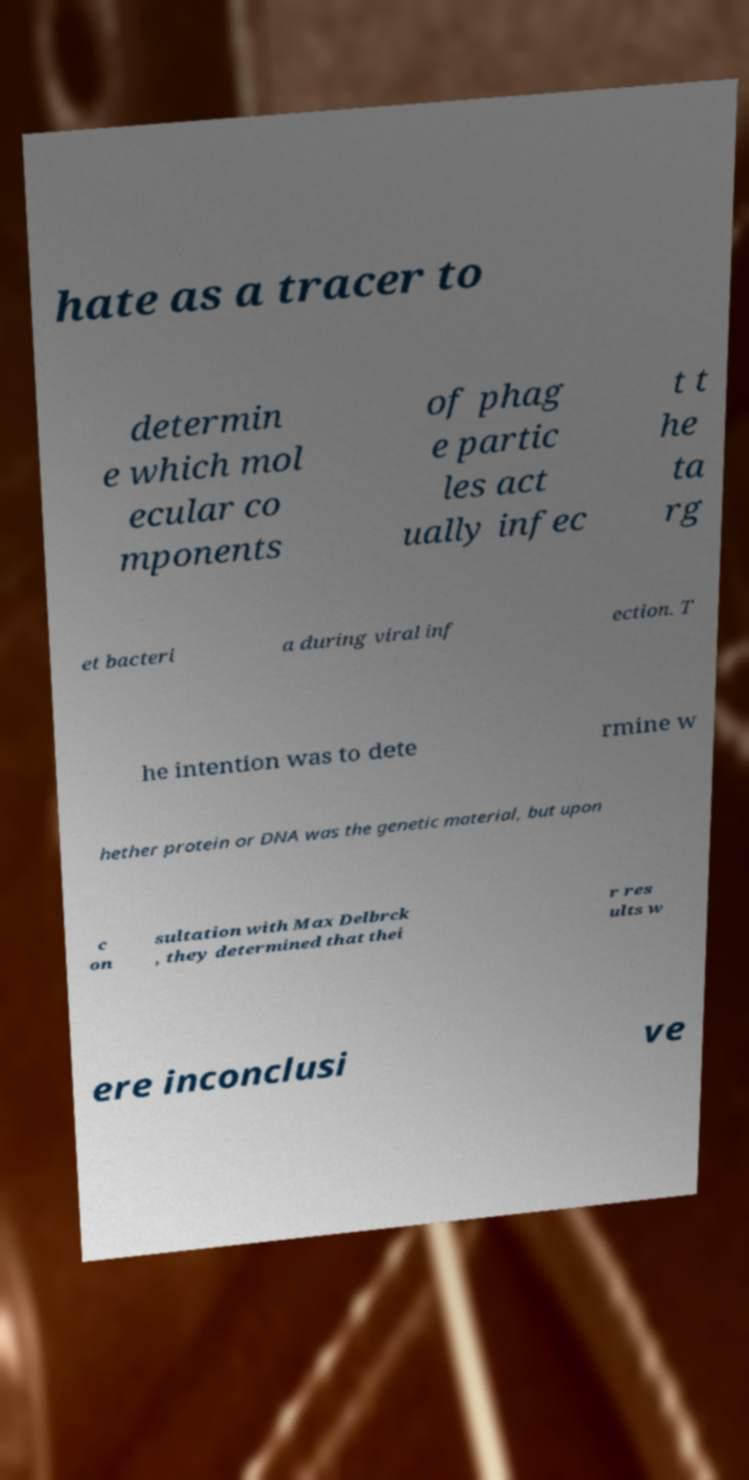For documentation purposes, I need the text within this image transcribed. Could you provide that? hate as a tracer to determin e which mol ecular co mponents of phag e partic les act ually infec t t he ta rg et bacteri a during viral inf ection. T he intention was to dete rmine w hether protein or DNA was the genetic material, but upon c on sultation with Max Delbrck , they determined that thei r res ults w ere inconclusi ve 